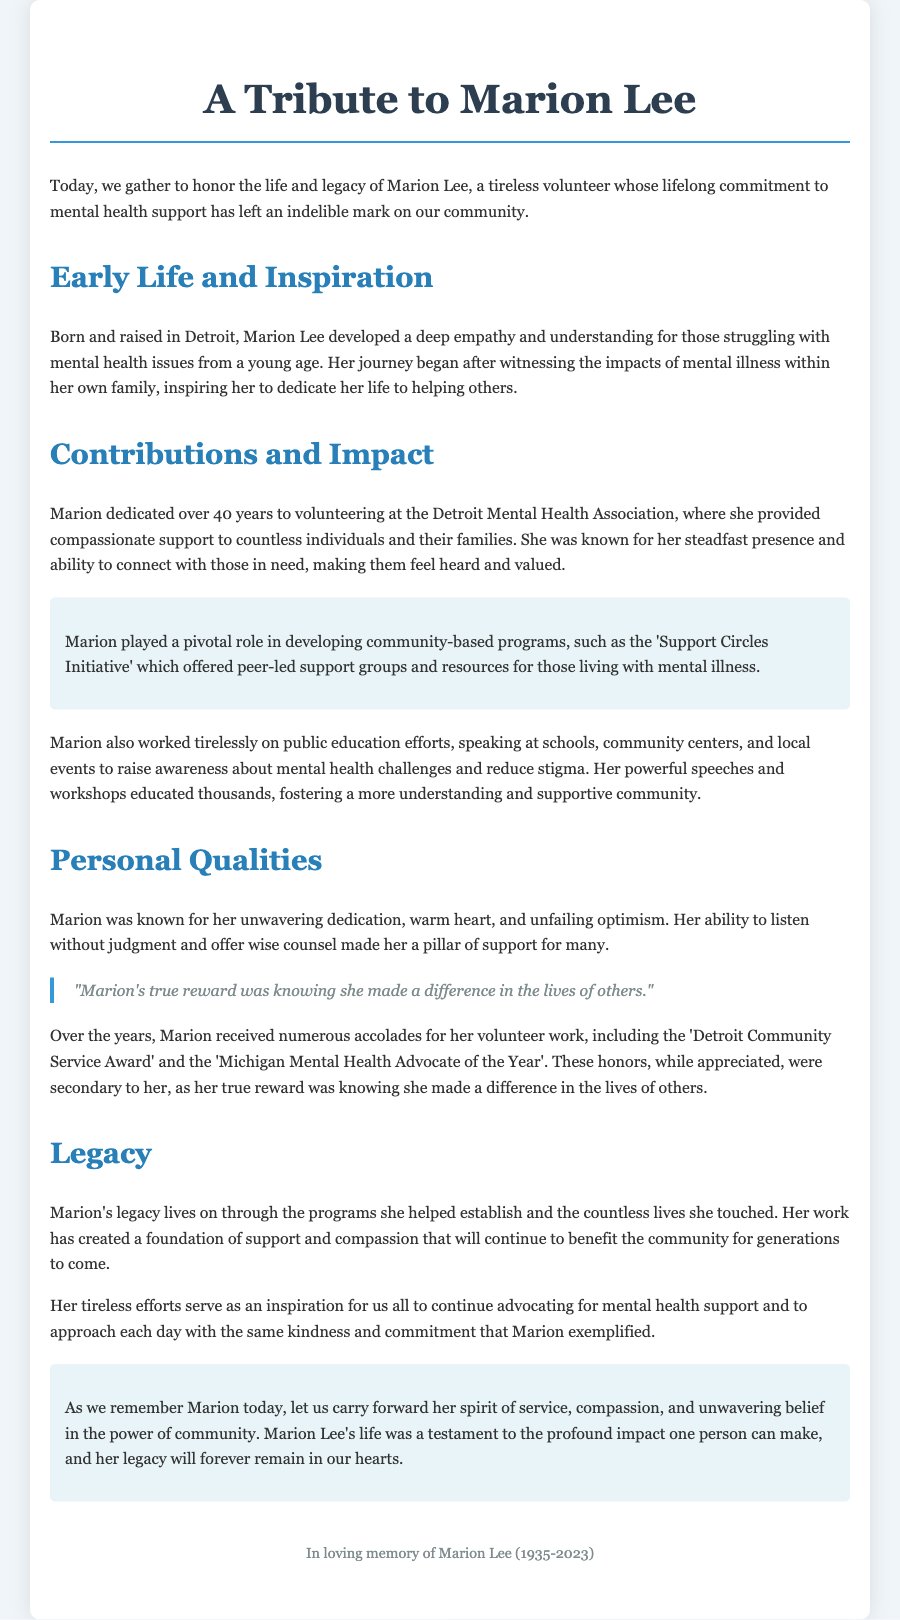What was Marion Lee's primary field of volunteer work? Marion Lee dedicated her volunteer efforts to mental health support in the community.
Answer: mental health support How many years did Marion volunteer at the Detroit Mental Health Association? It is stated that Marion dedicated over 40 years to volunteering in her field.
Answer: 40 years What initiative did Marion help develop? Marion played a pivotal role in developing the 'Support Circles Initiative'.
Answer: Support Circles Initiative Which significant award did Marion receive for her volunteer work? The document mentions the 'Detroit Community Service Award' among others.
Answer: Detroit Community Service Award What personal qualities was Marion known for? The document describes Marion as having unwavering dedication, warm heart, and unfailing optimism.
Answer: unwavering dedication, warm heart, and unfailing optimism Why did Marion consider her volunteer work rewarding? The document emphasizes that her true reward was knowing she made a difference in the lives of others.
Answer: made a difference in the lives of others In what year was Marion born? The document indicates that Marion Lee was born in 1935.
Answer: 1935 What does Marion's legacy encourage the community to continue? Marion's legacy inspires the community to continue advocating for mental health support.
Answer: advocating for mental health support 